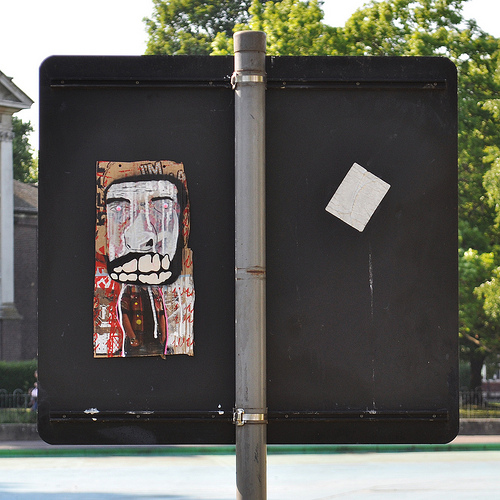<image>
Is the picture in front of the sign? No. The picture is not in front of the sign. The spatial positioning shows a different relationship between these objects. 